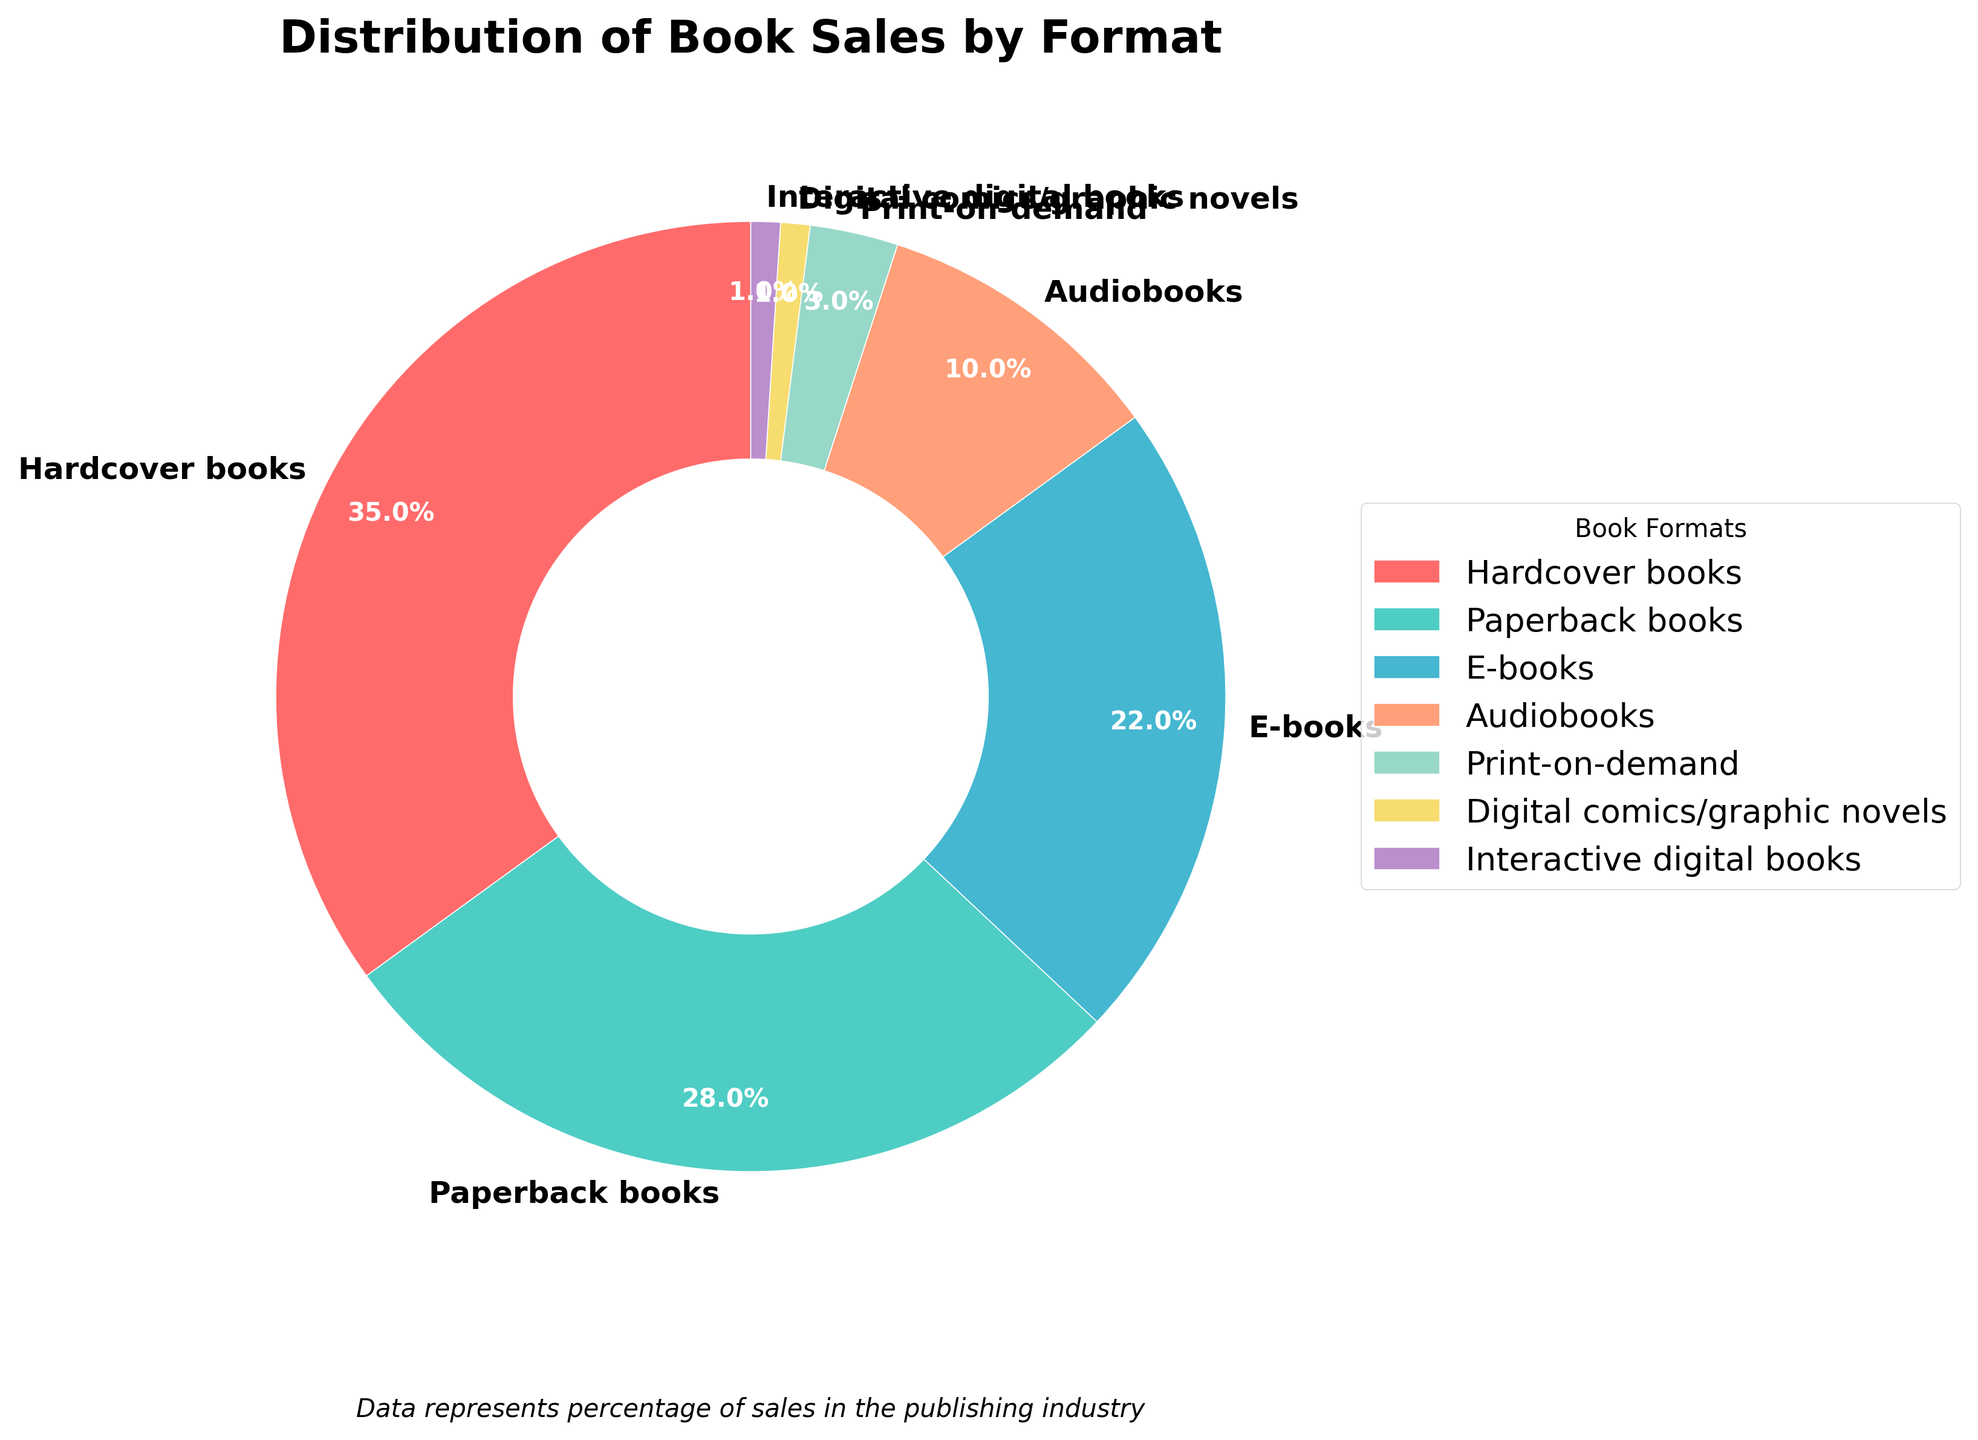What percentage of the market is occupied by traditional print formats (hardcover and paperback combined)? To find the percentage of traditional print formats combined, add the percentages of hardcover books and paperback books from the figure. Hardcover books represent 35%, and paperback books represent 28%. Adding these together gives 35% + 28% = 63%.
Answer: 63% Which format has the smallest market share? The figure shows that both digital comics/graphic novels and interactive digital books have the smallest market shares, each taking up 1% of the market.
Answer: Digital comics/graphic novels and Interactive digital books How does the market share of e-books compare to that of audiobooks? The figure shows that e-books occupy 22% of the market, while audiobooks occupy 10%. Therefore, e-books have a higher market share than audiobooks.
Answer: E-books have a higher market share than audiobooks What is the difference in market share between print-on-demand and interactive digital books? According to the figure, print-on-demand has a market share of 3%, while interactive digital books have a market share of 1%. The difference between them is 3% - 1% = 2%.
Answer: 2% Among digital formats (e-books, audiobooks, digital comics/graphic novels, interactive digital books), which has the largest market share? The figure indicates that e-books have the largest market share among digital formats, with 22%.
Answer: E-books If we grouped all digital formats together, what would be their combined market share? Adding the market shares of all digital formats from the figure: e-books(22%) + audiobooks(10%) + digital comics/graphic novels(1%) + interactive digital books(1%). The total is 22% + 10% + 1% + 1% = 34%.
Answer: 34% What is the combined market share of digital comics/graphic novels and interactive digital books? According to the figure, both digital comics/graphic novels and interactive digital books have 1% each. Adding these gives 1% + 1% = 2%.
Answer: 2% Which format is second largest in terms of market share? The figure shows that paperback books have the second-largest market share at 28%, following hardcover books at 35%.
Answer: Paperback books Are there more sales from audiobooks or from print-on-demand? The figure shows that audiobooks have a market share of 10%, while print-on-demand has a market share of 3%. Audiobooks have more sales.
Answer: Audiobooks How much more popular are hardcover books than e-books in terms of market share? The figure shows that hardcover books take up 35% of the market, while e-books cover 22%. The difference is 35% - 22% = 13%.
Answer: 13% 